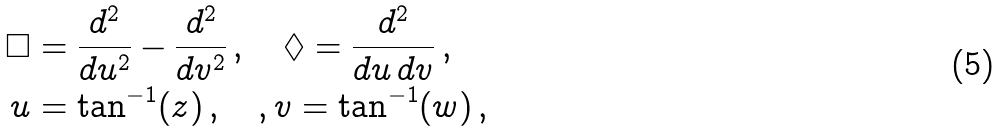<formula> <loc_0><loc_0><loc_500><loc_500>\Box & = \frac { d ^ { 2 } } { d u ^ { 2 } } - \frac { d ^ { 2 } } { d v ^ { 2 } } \, , \quad \Diamond = \frac { d ^ { 2 } } { d u \, d v } \, , \\ u & = \tan ^ { - 1 } ( z ) \, , \quad , v = \tan ^ { - 1 } ( w ) \, ,</formula> 